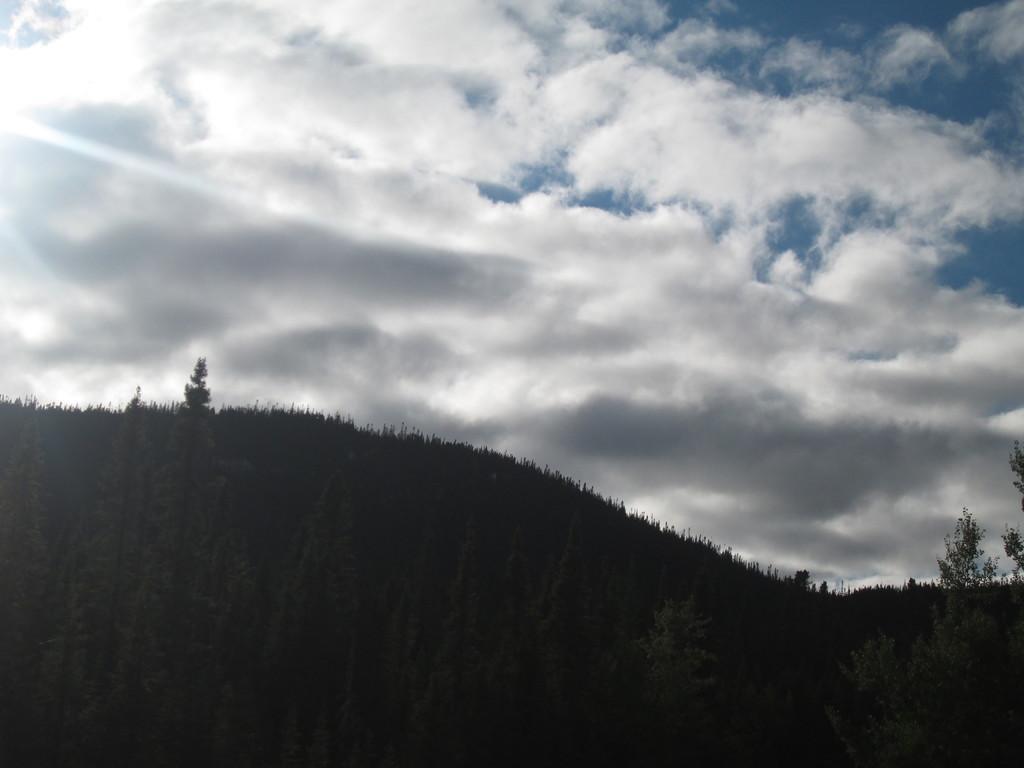Can you describe this image briefly? In this picture we can see a mountain. On the bottom we can see many trees. On the top we can see sky and clouds. On the top left corner there is a sun. 